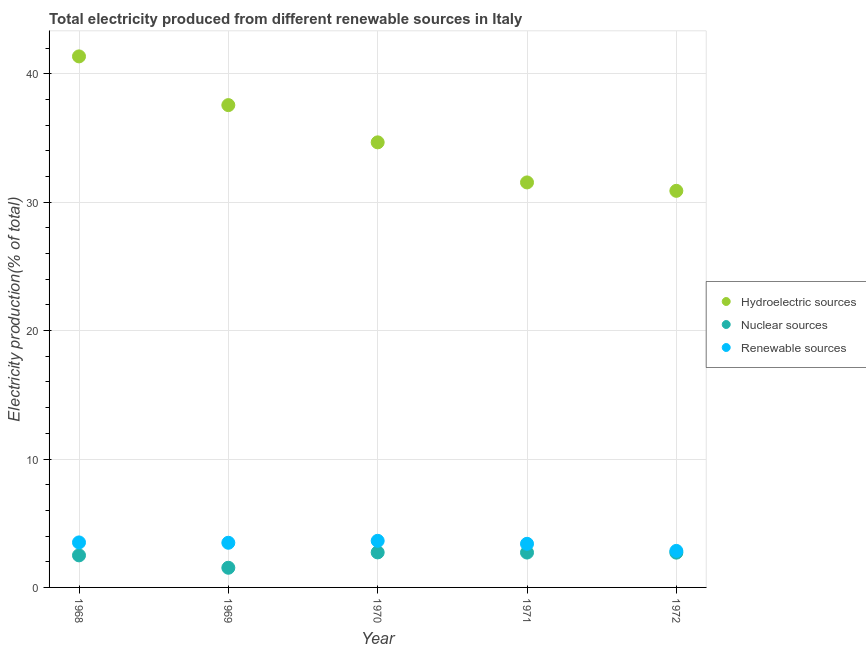How many different coloured dotlines are there?
Provide a short and direct response. 3. Is the number of dotlines equal to the number of legend labels?
Make the answer very short. Yes. What is the percentage of electricity produced by hydroelectric sources in 1970?
Offer a very short reply. 34.66. Across all years, what is the maximum percentage of electricity produced by nuclear sources?
Your response must be concise. 2.73. Across all years, what is the minimum percentage of electricity produced by renewable sources?
Your answer should be compact. 2.84. In which year was the percentage of electricity produced by renewable sources maximum?
Offer a very short reply. 1970. In which year was the percentage of electricity produced by hydroelectric sources minimum?
Offer a terse response. 1972. What is the total percentage of electricity produced by renewable sources in the graph?
Ensure brevity in your answer.  16.85. What is the difference between the percentage of electricity produced by renewable sources in 1969 and that in 1970?
Your response must be concise. -0.15. What is the difference between the percentage of electricity produced by renewable sources in 1969 and the percentage of electricity produced by nuclear sources in 1971?
Your answer should be very brief. 0.76. What is the average percentage of electricity produced by renewable sources per year?
Offer a terse response. 3.37. In the year 1968, what is the difference between the percentage of electricity produced by renewable sources and percentage of electricity produced by hydroelectric sources?
Keep it short and to the point. -37.84. What is the ratio of the percentage of electricity produced by nuclear sources in 1968 to that in 1972?
Your response must be concise. 0.92. Is the percentage of electricity produced by renewable sources in 1968 less than that in 1969?
Give a very brief answer. No. What is the difference between the highest and the second highest percentage of electricity produced by hydroelectric sources?
Give a very brief answer. 3.79. What is the difference between the highest and the lowest percentage of electricity produced by renewable sources?
Your response must be concise. 0.79. Is the sum of the percentage of electricity produced by renewable sources in 1969 and 1972 greater than the maximum percentage of electricity produced by hydroelectric sources across all years?
Your answer should be very brief. No. Is it the case that in every year, the sum of the percentage of electricity produced by hydroelectric sources and percentage of electricity produced by nuclear sources is greater than the percentage of electricity produced by renewable sources?
Provide a succinct answer. Yes. Does the percentage of electricity produced by nuclear sources monotonically increase over the years?
Your response must be concise. No. What is the difference between two consecutive major ticks on the Y-axis?
Your answer should be very brief. 10. How are the legend labels stacked?
Give a very brief answer. Vertical. What is the title of the graph?
Provide a succinct answer. Total electricity produced from different renewable sources in Italy. What is the label or title of the X-axis?
Your response must be concise. Year. What is the Electricity production(% of total) of Hydroelectric sources in 1968?
Give a very brief answer. 41.35. What is the Electricity production(% of total) of Nuclear sources in 1968?
Provide a short and direct response. 2.5. What is the Electricity production(% of total) in Renewable sources in 1968?
Offer a very short reply. 3.5. What is the Electricity production(% of total) of Hydroelectric sources in 1969?
Ensure brevity in your answer.  37.56. What is the Electricity production(% of total) in Nuclear sources in 1969?
Provide a short and direct response. 1.53. What is the Electricity production(% of total) in Renewable sources in 1969?
Offer a very short reply. 3.48. What is the Electricity production(% of total) of Hydroelectric sources in 1970?
Ensure brevity in your answer.  34.66. What is the Electricity production(% of total) of Nuclear sources in 1970?
Make the answer very short. 2.73. What is the Electricity production(% of total) in Renewable sources in 1970?
Make the answer very short. 3.63. What is the Electricity production(% of total) in Hydroelectric sources in 1971?
Provide a succinct answer. 31.54. What is the Electricity production(% of total) of Nuclear sources in 1971?
Make the answer very short. 2.72. What is the Electricity production(% of total) in Renewable sources in 1971?
Your response must be concise. 3.4. What is the Electricity production(% of total) of Hydroelectric sources in 1972?
Keep it short and to the point. 30.88. What is the Electricity production(% of total) in Nuclear sources in 1972?
Make the answer very short. 2.71. What is the Electricity production(% of total) of Renewable sources in 1972?
Ensure brevity in your answer.  2.84. Across all years, what is the maximum Electricity production(% of total) of Hydroelectric sources?
Offer a very short reply. 41.35. Across all years, what is the maximum Electricity production(% of total) of Nuclear sources?
Provide a short and direct response. 2.73. Across all years, what is the maximum Electricity production(% of total) in Renewable sources?
Provide a succinct answer. 3.63. Across all years, what is the minimum Electricity production(% of total) in Hydroelectric sources?
Ensure brevity in your answer.  30.88. Across all years, what is the minimum Electricity production(% of total) in Nuclear sources?
Give a very brief answer. 1.53. Across all years, what is the minimum Electricity production(% of total) of Renewable sources?
Keep it short and to the point. 2.84. What is the total Electricity production(% of total) of Hydroelectric sources in the graph?
Provide a succinct answer. 175.98. What is the total Electricity production(% of total) of Nuclear sources in the graph?
Keep it short and to the point. 12.18. What is the total Electricity production(% of total) in Renewable sources in the graph?
Give a very brief answer. 16.85. What is the difference between the Electricity production(% of total) in Hydroelectric sources in 1968 and that in 1969?
Your answer should be compact. 3.79. What is the difference between the Electricity production(% of total) in Nuclear sources in 1968 and that in 1969?
Provide a short and direct response. 0.96. What is the difference between the Electricity production(% of total) of Renewable sources in 1968 and that in 1969?
Give a very brief answer. 0.03. What is the difference between the Electricity production(% of total) of Hydroelectric sources in 1968 and that in 1970?
Offer a very short reply. 6.69. What is the difference between the Electricity production(% of total) in Nuclear sources in 1968 and that in 1970?
Your answer should be very brief. -0.23. What is the difference between the Electricity production(% of total) of Renewable sources in 1968 and that in 1970?
Ensure brevity in your answer.  -0.12. What is the difference between the Electricity production(% of total) in Hydroelectric sources in 1968 and that in 1971?
Provide a short and direct response. 9.81. What is the difference between the Electricity production(% of total) of Nuclear sources in 1968 and that in 1971?
Offer a terse response. -0.22. What is the difference between the Electricity production(% of total) in Renewable sources in 1968 and that in 1971?
Ensure brevity in your answer.  0.11. What is the difference between the Electricity production(% of total) in Hydroelectric sources in 1968 and that in 1972?
Offer a very short reply. 10.47. What is the difference between the Electricity production(% of total) of Nuclear sources in 1968 and that in 1972?
Ensure brevity in your answer.  -0.21. What is the difference between the Electricity production(% of total) in Renewable sources in 1968 and that in 1972?
Your response must be concise. 0.66. What is the difference between the Electricity production(% of total) of Hydroelectric sources in 1969 and that in 1970?
Your answer should be very brief. 2.9. What is the difference between the Electricity production(% of total) in Nuclear sources in 1969 and that in 1970?
Make the answer very short. -1.19. What is the difference between the Electricity production(% of total) in Renewable sources in 1969 and that in 1970?
Offer a terse response. -0.15. What is the difference between the Electricity production(% of total) in Hydroelectric sources in 1969 and that in 1971?
Provide a succinct answer. 6.02. What is the difference between the Electricity production(% of total) of Nuclear sources in 1969 and that in 1971?
Your answer should be compact. -1.18. What is the difference between the Electricity production(% of total) in Renewable sources in 1969 and that in 1971?
Ensure brevity in your answer.  0.08. What is the difference between the Electricity production(% of total) of Hydroelectric sources in 1969 and that in 1972?
Provide a short and direct response. 6.67. What is the difference between the Electricity production(% of total) in Nuclear sources in 1969 and that in 1972?
Offer a very short reply. -1.18. What is the difference between the Electricity production(% of total) of Renewable sources in 1969 and that in 1972?
Your answer should be very brief. 0.63. What is the difference between the Electricity production(% of total) in Hydroelectric sources in 1970 and that in 1971?
Offer a terse response. 3.12. What is the difference between the Electricity production(% of total) in Nuclear sources in 1970 and that in 1971?
Offer a very short reply. 0.01. What is the difference between the Electricity production(% of total) of Renewable sources in 1970 and that in 1971?
Offer a terse response. 0.23. What is the difference between the Electricity production(% of total) of Hydroelectric sources in 1970 and that in 1972?
Offer a terse response. 3.77. What is the difference between the Electricity production(% of total) of Nuclear sources in 1970 and that in 1972?
Give a very brief answer. 0.02. What is the difference between the Electricity production(% of total) in Renewable sources in 1970 and that in 1972?
Your response must be concise. 0.79. What is the difference between the Electricity production(% of total) of Hydroelectric sources in 1971 and that in 1972?
Provide a short and direct response. 0.65. What is the difference between the Electricity production(% of total) of Nuclear sources in 1971 and that in 1972?
Offer a terse response. 0.01. What is the difference between the Electricity production(% of total) in Renewable sources in 1971 and that in 1972?
Your answer should be very brief. 0.55. What is the difference between the Electricity production(% of total) of Hydroelectric sources in 1968 and the Electricity production(% of total) of Nuclear sources in 1969?
Provide a short and direct response. 39.82. What is the difference between the Electricity production(% of total) of Hydroelectric sources in 1968 and the Electricity production(% of total) of Renewable sources in 1969?
Give a very brief answer. 37.87. What is the difference between the Electricity production(% of total) in Nuclear sources in 1968 and the Electricity production(% of total) in Renewable sources in 1969?
Make the answer very short. -0.98. What is the difference between the Electricity production(% of total) of Hydroelectric sources in 1968 and the Electricity production(% of total) of Nuclear sources in 1970?
Your answer should be compact. 38.62. What is the difference between the Electricity production(% of total) in Hydroelectric sources in 1968 and the Electricity production(% of total) in Renewable sources in 1970?
Your answer should be compact. 37.72. What is the difference between the Electricity production(% of total) in Nuclear sources in 1968 and the Electricity production(% of total) in Renewable sources in 1970?
Your response must be concise. -1.13. What is the difference between the Electricity production(% of total) in Hydroelectric sources in 1968 and the Electricity production(% of total) in Nuclear sources in 1971?
Provide a succinct answer. 38.63. What is the difference between the Electricity production(% of total) of Hydroelectric sources in 1968 and the Electricity production(% of total) of Renewable sources in 1971?
Provide a short and direct response. 37.95. What is the difference between the Electricity production(% of total) of Nuclear sources in 1968 and the Electricity production(% of total) of Renewable sources in 1971?
Give a very brief answer. -0.9. What is the difference between the Electricity production(% of total) in Hydroelectric sources in 1968 and the Electricity production(% of total) in Nuclear sources in 1972?
Your response must be concise. 38.64. What is the difference between the Electricity production(% of total) of Hydroelectric sources in 1968 and the Electricity production(% of total) of Renewable sources in 1972?
Ensure brevity in your answer.  38.51. What is the difference between the Electricity production(% of total) in Nuclear sources in 1968 and the Electricity production(% of total) in Renewable sources in 1972?
Offer a terse response. -0.35. What is the difference between the Electricity production(% of total) in Hydroelectric sources in 1969 and the Electricity production(% of total) in Nuclear sources in 1970?
Your answer should be very brief. 34.83. What is the difference between the Electricity production(% of total) of Hydroelectric sources in 1969 and the Electricity production(% of total) of Renewable sources in 1970?
Your answer should be compact. 33.93. What is the difference between the Electricity production(% of total) in Nuclear sources in 1969 and the Electricity production(% of total) in Renewable sources in 1970?
Your response must be concise. -2.1. What is the difference between the Electricity production(% of total) in Hydroelectric sources in 1969 and the Electricity production(% of total) in Nuclear sources in 1971?
Offer a very short reply. 34.84. What is the difference between the Electricity production(% of total) in Hydroelectric sources in 1969 and the Electricity production(% of total) in Renewable sources in 1971?
Your response must be concise. 34.16. What is the difference between the Electricity production(% of total) in Nuclear sources in 1969 and the Electricity production(% of total) in Renewable sources in 1971?
Give a very brief answer. -1.86. What is the difference between the Electricity production(% of total) in Hydroelectric sources in 1969 and the Electricity production(% of total) in Nuclear sources in 1972?
Offer a very short reply. 34.85. What is the difference between the Electricity production(% of total) in Hydroelectric sources in 1969 and the Electricity production(% of total) in Renewable sources in 1972?
Make the answer very short. 34.71. What is the difference between the Electricity production(% of total) in Nuclear sources in 1969 and the Electricity production(% of total) in Renewable sources in 1972?
Offer a very short reply. -1.31. What is the difference between the Electricity production(% of total) in Hydroelectric sources in 1970 and the Electricity production(% of total) in Nuclear sources in 1971?
Ensure brevity in your answer.  31.94. What is the difference between the Electricity production(% of total) of Hydroelectric sources in 1970 and the Electricity production(% of total) of Renewable sources in 1971?
Offer a very short reply. 31.26. What is the difference between the Electricity production(% of total) of Nuclear sources in 1970 and the Electricity production(% of total) of Renewable sources in 1971?
Offer a very short reply. -0.67. What is the difference between the Electricity production(% of total) of Hydroelectric sources in 1970 and the Electricity production(% of total) of Nuclear sources in 1972?
Ensure brevity in your answer.  31.95. What is the difference between the Electricity production(% of total) of Hydroelectric sources in 1970 and the Electricity production(% of total) of Renewable sources in 1972?
Ensure brevity in your answer.  31.81. What is the difference between the Electricity production(% of total) of Nuclear sources in 1970 and the Electricity production(% of total) of Renewable sources in 1972?
Make the answer very short. -0.12. What is the difference between the Electricity production(% of total) in Hydroelectric sources in 1971 and the Electricity production(% of total) in Nuclear sources in 1972?
Provide a short and direct response. 28.83. What is the difference between the Electricity production(% of total) in Hydroelectric sources in 1971 and the Electricity production(% of total) in Renewable sources in 1972?
Your answer should be compact. 28.69. What is the difference between the Electricity production(% of total) of Nuclear sources in 1971 and the Electricity production(% of total) of Renewable sources in 1972?
Provide a succinct answer. -0.13. What is the average Electricity production(% of total) in Hydroelectric sources per year?
Give a very brief answer. 35.2. What is the average Electricity production(% of total) in Nuclear sources per year?
Keep it short and to the point. 2.44. What is the average Electricity production(% of total) of Renewable sources per year?
Provide a succinct answer. 3.37. In the year 1968, what is the difference between the Electricity production(% of total) in Hydroelectric sources and Electricity production(% of total) in Nuclear sources?
Your answer should be compact. 38.85. In the year 1968, what is the difference between the Electricity production(% of total) in Hydroelectric sources and Electricity production(% of total) in Renewable sources?
Provide a succinct answer. 37.84. In the year 1968, what is the difference between the Electricity production(% of total) of Nuclear sources and Electricity production(% of total) of Renewable sources?
Your answer should be compact. -1.01. In the year 1969, what is the difference between the Electricity production(% of total) in Hydroelectric sources and Electricity production(% of total) in Nuclear sources?
Provide a succinct answer. 36.02. In the year 1969, what is the difference between the Electricity production(% of total) in Hydroelectric sources and Electricity production(% of total) in Renewable sources?
Keep it short and to the point. 34.08. In the year 1969, what is the difference between the Electricity production(% of total) in Nuclear sources and Electricity production(% of total) in Renewable sources?
Keep it short and to the point. -1.95. In the year 1970, what is the difference between the Electricity production(% of total) in Hydroelectric sources and Electricity production(% of total) in Nuclear sources?
Keep it short and to the point. 31.93. In the year 1970, what is the difference between the Electricity production(% of total) of Hydroelectric sources and Electricity production(% of total) of Renewable sources?
Ensure brevity in your answer.  31.03. In the year 1970, what is the difference between the Electricity production(% of total) of Nuclear sources and Electricity production(% of total) of Renewable sources?
Give a very brief answer. -0.9. In the year 1971, what is the difference between the Electricity production(% of total) of Hydroelectric sources and Electricity production(% of total) of Nuclear sources?
Provide a succinct answer. 28.82. In the year 1971, what is the difference between the Electricity production(% of total) of Hydroelectric sources and Electricity production(% of total) of Renewable sources?
Your answer should be compact. 28.14. In the year 1971, what is the difference between the Electricity production(% of total) in Nuclear sources and Electricity production(% of total) in Renewable sources?
Your response must be concise. -0.68. In the year 1972, what is the difference between the Electricity production(% of total) of Hydroelectric sources and Electricity production(% of total) of Nuclear sources?
Offer a very short reply. 28.17. In the year 1972, what is the difference between the Electricity production(% of total) of Hydroelectric sources and Electricity production(% of total) of Renewable sources?
Offer a very short reply. 28.04. In the year 1972, what is the difference between the Electricity production(% of total) in Nuclear sources and Electricity production(% of total) in Renewable sources?
Provide a short and direct response. -0.14. What is the ratio of the Electricity production(% of total) of Hydroelectric sources in 1968 to that in 1969?
Keep it short and to the point. 1.1. What is the ratio of the Electricity production(% of total) of Nuclear sources in 1968 to that in 1969?
Give a very brief answer. 1.63. What is the ratio of the Electricity production(% of total) of Renewable sources in 1968 to that in 1969?
Give a very brief answer. 1.01. What is the ratio of the Electricity production(% of total) of Hydroelectric sources in 1968 to that in 1970?
Provide a short and direct response. 1.19. What is the ratio of the Electricity production(% of total) of Nuclear sources in 1968 to that in 1970?
Provide a succinct answer. 0.92. What is the ratio of the Electricity production(% of total) of Renewable sources in 1968 to that in 1970?
Give a very brief answer. 0.97. What is the ratio of the Electricity production(% of total) in Hydroelectric sources in 1968 to that in 1971?
Ensure brevity in your answer.  1.31. What is the ratio of the Electricity production(% of total) of Nuclear sources in 1968 to that in 1971?
Your answer should be compact. 0.92. What is the ratio of the Electricity production(% of total) of Renewable sources in 1968 to that in 1971?
Your answer should be compact. 1.03. What is the ratio of the Electricity production(% of total) in Hydroelectric sources in 1968 to that in 1972?
Provide a short and direct response. 1.34. What is the ratio of the Electricity production(% of total) in Nuclear sources in 1968 to that in 1972?
Your answer should be compact. 0.92. What is the ratio of the Electricity production(% of total) of Renewable sources in 1968 to that in 1972?
Keep it short and to the point. 1.23. What is the ratio of the Electricity production(% of total) of Hydroelectric sources in 1969 to that in 1970?
Offer a terse response. 1.08. What is the ratio of the Electricity production(% of total) of Nuclear sources in 1969 to that in 1970?
Offer a terse response. 0.56. What is the ratio of the Electricity production(% of total) of Renewable sources in 1969 to that in 1970?
Ensure brevity in your answer.  0.96. What is the ratio of the Electricity production(% of total) in Hydroelectric sources in 1969 to that in 1971?
Provide a short and direct response. 1.19. What is the ratio of the Electricity production(% of total) in Nuclear sources in 1969 to that in 1971?
Provide a short and direct response. 0.56. What is the ratio of the Electricity production(% of total) in Renewable sources in 1969 to that in 1971?
Keep it short and to the point. 1.02. What is the ratio of the Electricity production(% of total) in Hydroelectric sources in 1969 to that in 1972?
Keep it short and to the point. 1.22. What is the ratio of the Electricity production(% of total) in Nuclear sources in 1969 to that in 1972?
Make the answer very short. 0.57. What is the ratio of the Electricity production(% of total) in Renewable sources in 1969 to that in 1972?
Ensure brevity in your answer.  1.22. What is the ratio of the Electricity production(% of total) in Hydroelectric sources in 1970 to that in 1971?
Keep it short and to the point. 1.1. What is the ratio of the Electricity production(% of total) of Renewable sources in 1970 to that in 1971?
Your response must be concise. 1.07. What is the ratio of the Electricity production(% of total) in Hydroelectric sources in 1970 to that in 1972?
Offer a very short reply. 1.12. What is the ratio of the Electricity production(% of total) in Nuclear sources in 1970 to that in 1972?
Provide a short and direct response. 1.01. What is the ratio of the Electricity production(% of total) of Renewable sources in 1970 to that in 1972?
Give a very brief answer. 1.28. What is the ratio of the Electricity production(% of total) in Hydroelectric sources in 1971 to that in 1972?
Your answer should be very brief. 1.02. What is the ratio of the Electricity production(% of total) of Renewable sources in 1971 to that in 1972?
Your response must be concise. 1.19. What is the difference between the highest and the second highest Electricity production(% of total) in Hydroelectric sources?
Make the answer very short. 3.79. What is the difference between the highest and the second highest Electricity production(% of total) in Nuclear sources?
Ensure brevity in your answer.  0.01. What is the difference between the highest and the second highest Electricity production(% of total) in Renewable sources?
Your response must be concise. 0.12. What is the difference between the highest and the lowest Electricity production(% of total) in Hydroelectric sources?
Give a very brief answer. 10.47. What is the difference between the highest and the lowest Electricity production(% of total) of Nuclear sources?
Your response must be concise. 1.19. What is the difference between the highest and the lowest Electricity production(% of total) in Renewable sources?
Offer a terse response. 0.79. 